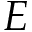<formula> <loc_0><loc_0><loc_500><loc_500>E</formula> 